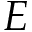<formula> <loc_0><loc_0><loc_500><loc_500>E</formula> 